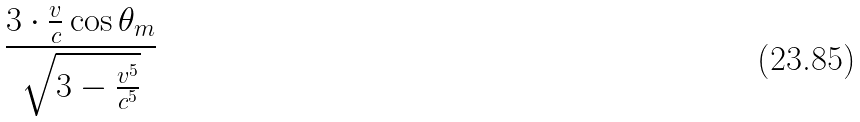Convert formula to latex. <formula><loc_0><loc_0><loc_500><loc_500>\frac { 3 \cdot \frac { v } { c } \cos \theta _ { m } } { \sqrt { 3 - \frac { v ^ { 5 } } { c ^ { 5 } } } }</formula> 